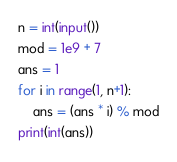<code> <loc_0><loc_0><loc_500><loc_500><_Python_>n = int(input())
mod = 1e9 + 7
ans = 1
for i in range(1, n+1):
    ans = (ans * i) % mod
print(int(ans))
</code> 